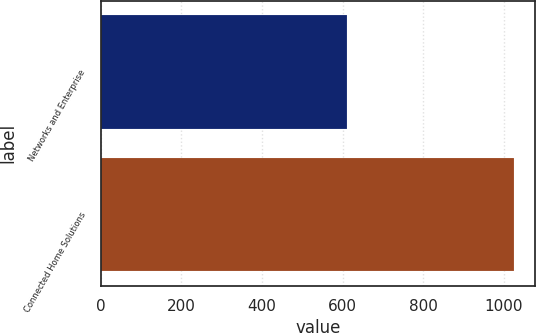Convert chart. <chart><loc_0><loc_0><loc_500><loc_500><bar_chart><fcel>Networks and Enterprise<fcel>Connected Home Solutions<nl><fcel>611<fcel>1026<nl></chart> 